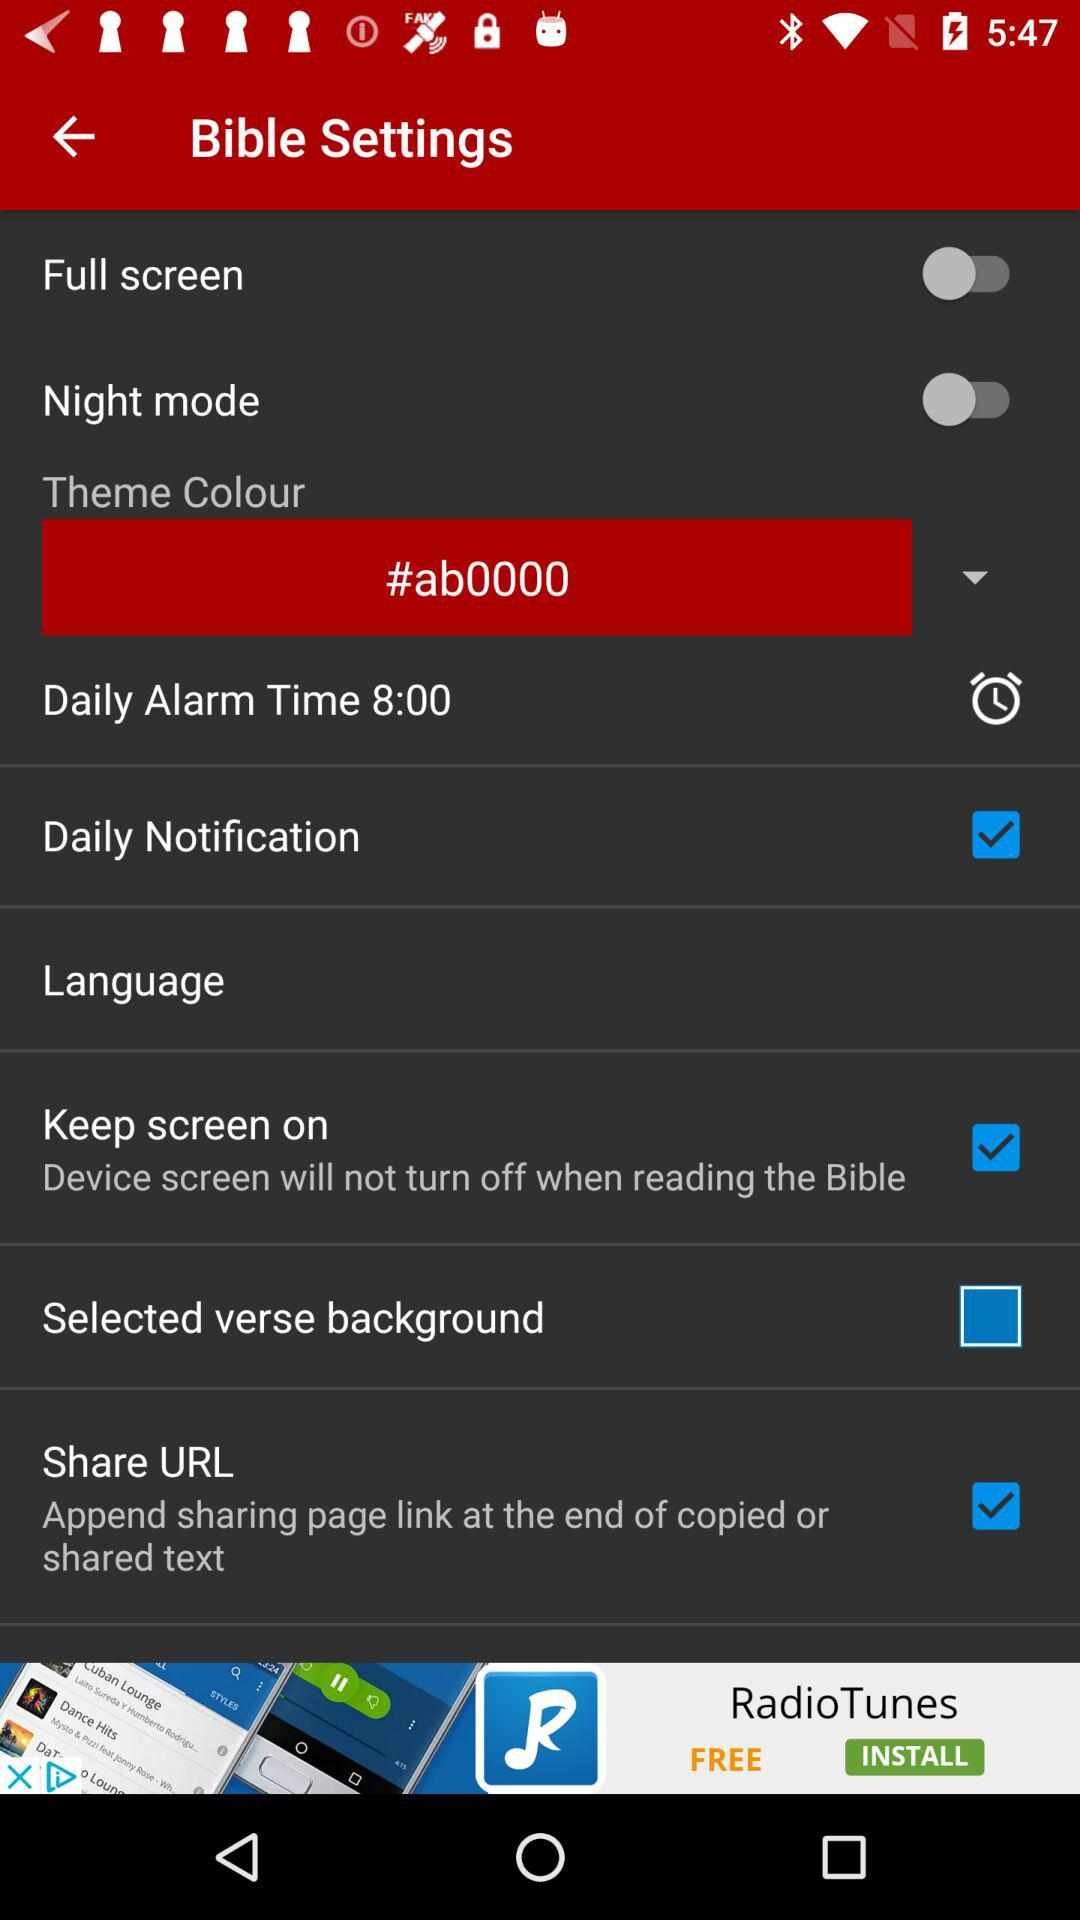What is the status of "Full screen"? The status is "off". 